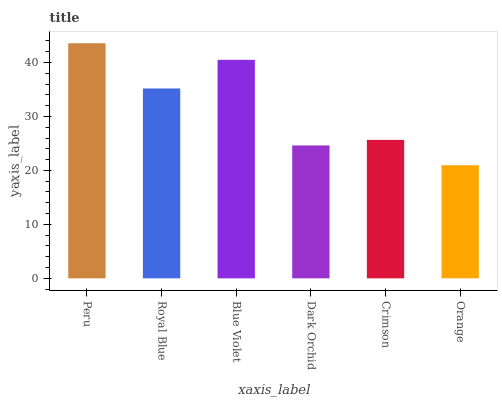Is Royal Blue the minimum?
Answer yes or no. No. Is Royal Blue the maximum?
Answer yes or no. No. Is Peru greater than Royal Blue?
Answer yes or no. Yes. Is Royal Blue less than Peru?
Answer yes or no. Yes. Is Royal Blue greater than Peru?
Answer yes or no. No. Is Peru less than Royal Blue?
Answer yes or no. No. Is Royal Blue the high median?
Answer yes or no. Yes. Is Crimson the low median?
Answer yes or no. Yes. Is Peru the high median?
Answer yes or no. No. Is Blue Violet the low median?
Answer yes or no. No. 